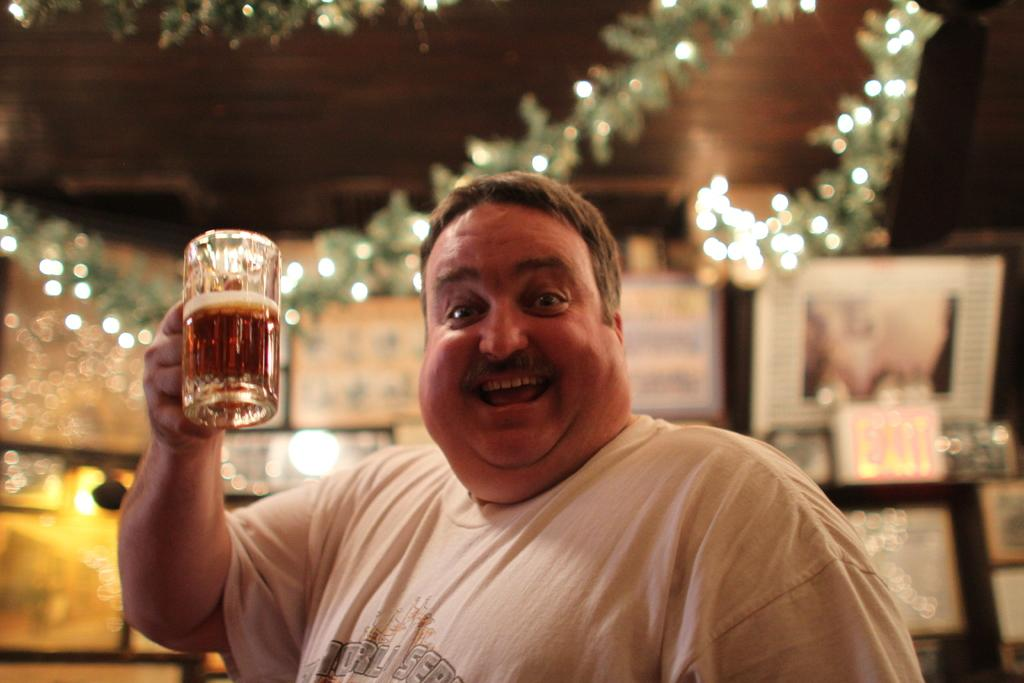What is the main subject of the image? There is a man in the image. What is the man doing in the image? The man is standing in the image. What is the man's facial expression in the image? The man is smiling in the image. What object is the man holding in the image? The man is holding a glass in the image. What type of bone can be seen in the man's hand in the image? There is no bone present in the image; the man is holding a glass. Can you describe the snail's shell in the image? There is no snail present in the image. 